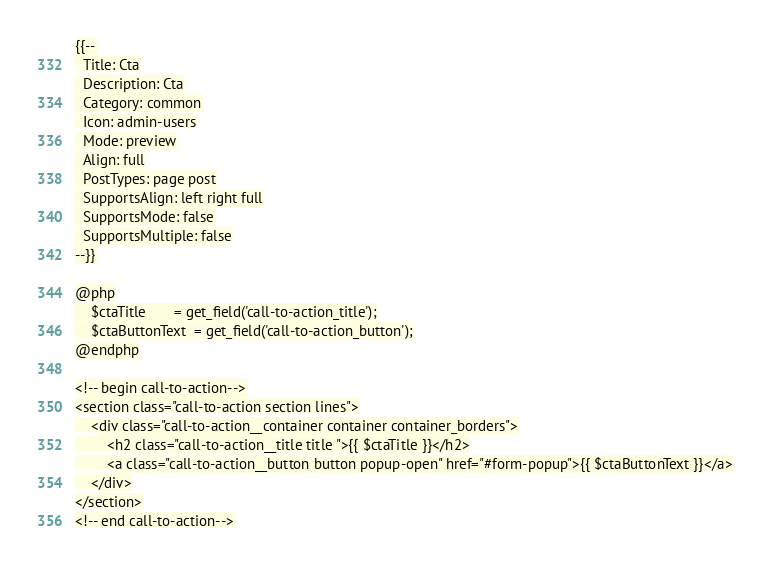<code> <loc_0><loc_0><loc_500><loc_500><_PHP_>{{--
  Title: Cta
  Description: Cta
  Category: common
  Icon: admin-users
  Mode: preview
  Align: full
  PostTypes: page post
  SupportsAlign: left right full
  SupportsMode: false
  SupportsMultiple: false
--}}

@php
	$ctaTitle       = get_field('call-to-action_title');
	$ctaButtonText  = get_field('call-to-action_button');
@endphp

<!-- begin call-to-action-->
<section class="call-to-action section lines">
	<div class="call-to-action__container container container_borders">
		<h2 class="call-to-action__title title ">{{ $ctaTitle }}</h2>
		<a class="call-to-action__button button popup-open" href="#form-popup">{{ $ctaButtonText }}</a>
	</div>
</section>
<!-- end call-to-action--></code> 